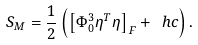<formula> <loc_0><loc_0><loc_500><loc_500>S _ { M } = \frac { 1 } { 2 } \left ( \left [ \Phi _ { 0 } ^ { 3 } \eta ^ { T } \eta \right ] _ { F } + \ h c \right ) .</formula> 